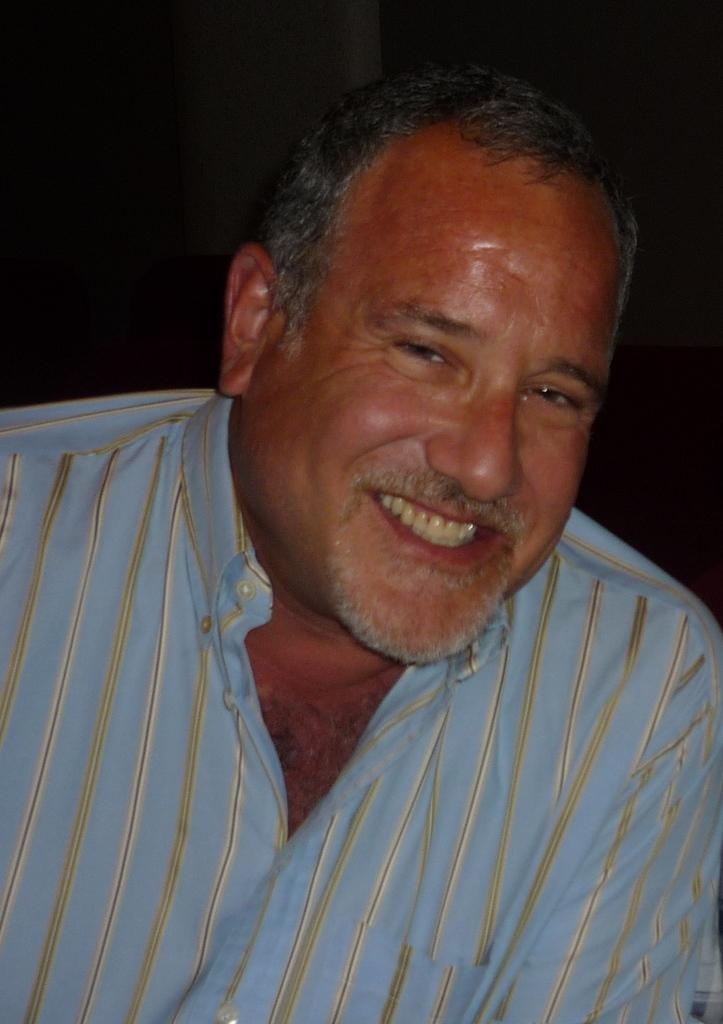Who is present in the image? There is a man in the image. What is the man wearing? The man is wearing a shirt. What is the man's facial expression? The man is smiling. What can be observed about the background of the image? The background of the image is dark. What type of respect can be seen in the image? There is no specific type of respect visible in the image; it features a man wearing a shirt and smiling against a dark background. How many chickens are present in the image? There are no chickens present in the image. 